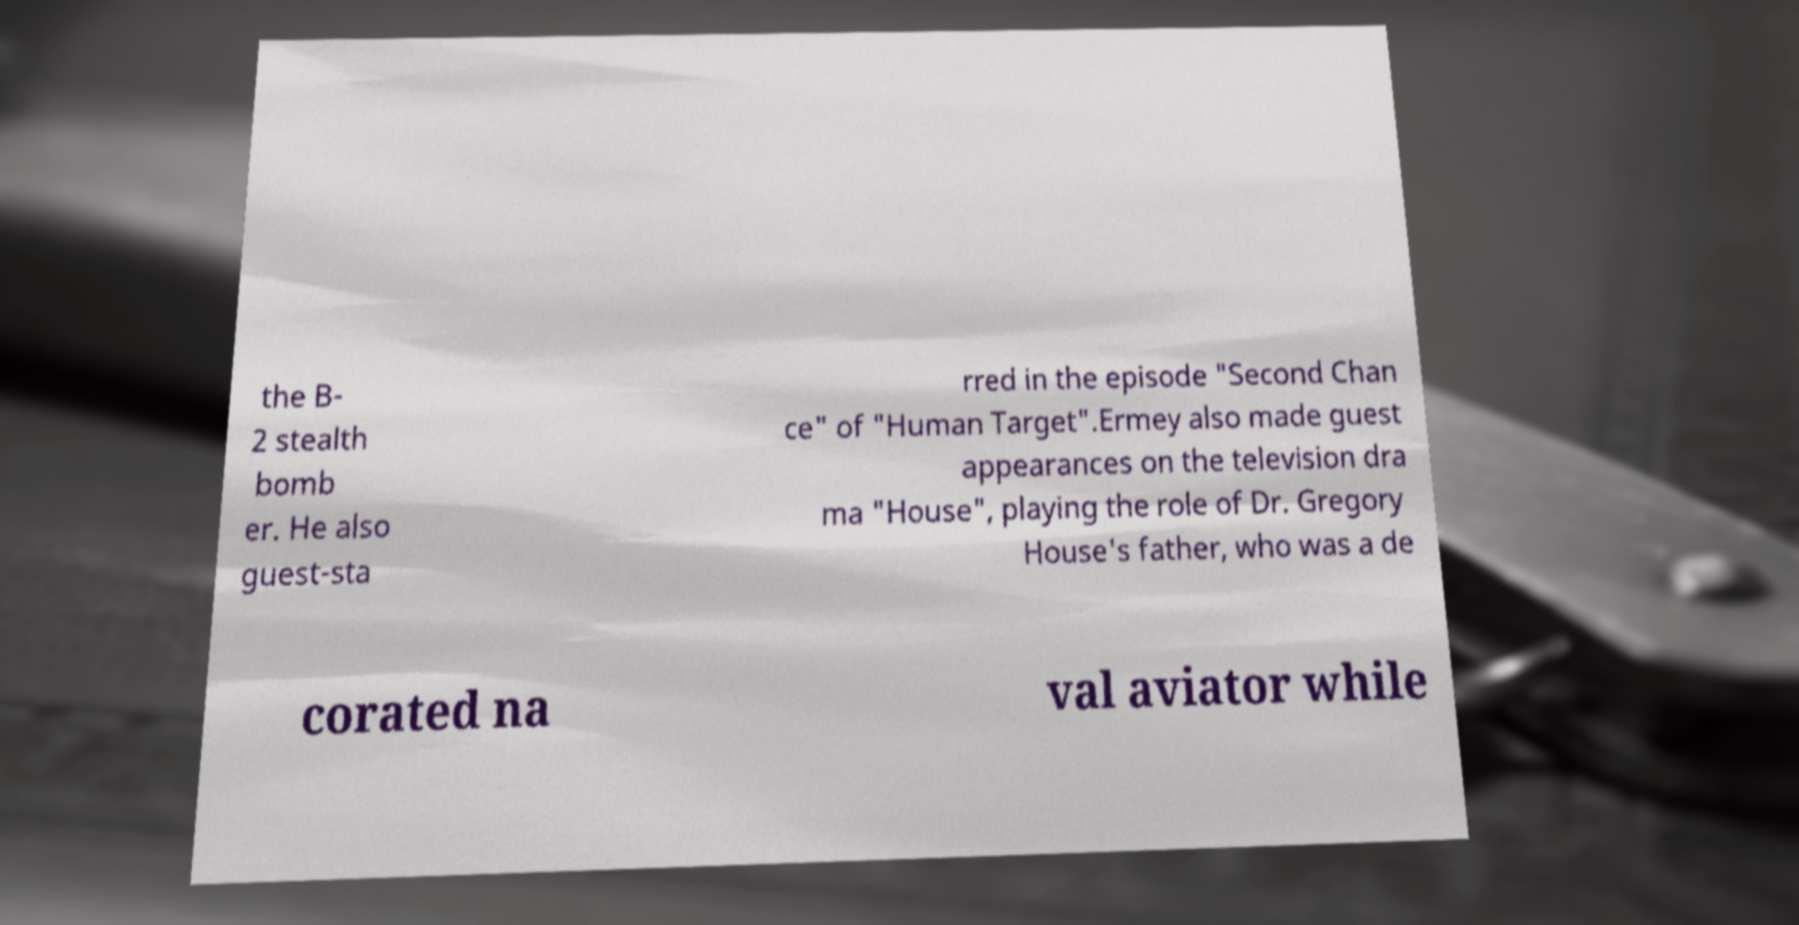For documentation purposes, I need the text within this image transcribed. Could you provide that? the B- 2 stealth bomb er. He also guest-sta rred in the episode "Second Chan ce" of "Human Target".Ermey also made guest appearances on the television dra ma "House", playing the role of Dr. Gregory House's father, who was a de corated na val aviator while 